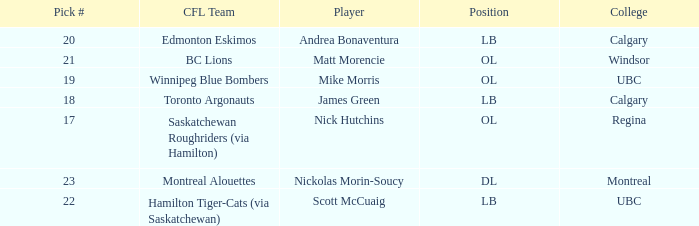What position is the player who went to Regina?  OL. 